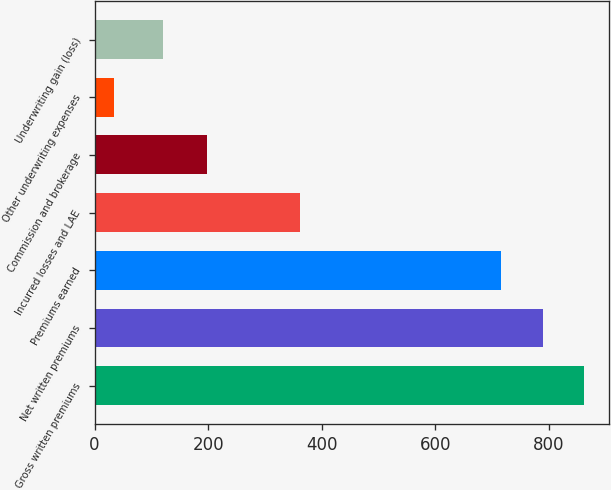<chart> <loc_0><loc_0><loc_500><loc_500><bar_chart><fcel>Gross written premiums<fcel>Net written premiums<fcel>Premiums earned<fcel>Incurred losses and LAE<fcel>Commission and brokerage<fcel>Other underwriting expenses<fcel>Underwriting gain (loss)<nl><fcel>862.76<fcel>789.23<fcel>715.7<fcel>361.8<fcel>198.8<fcel>34.9<fcel>120.2<nl></chart> 